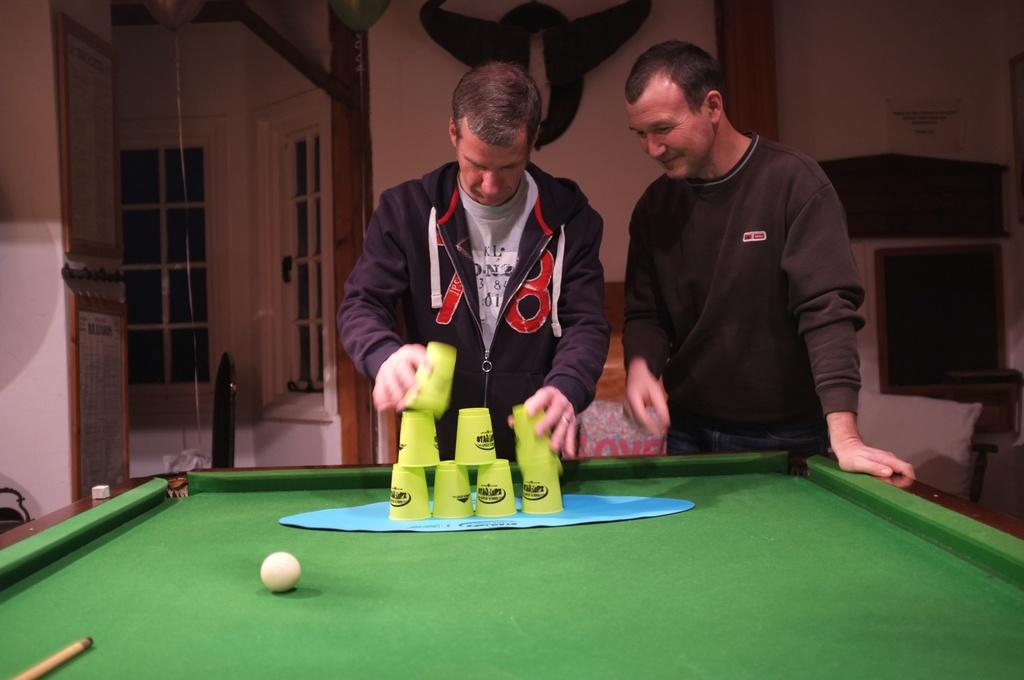How many people are in the image? There are two persons in the image. What are the persons doing in the image? The persons are playing with glasses. What game is being played in the image? The game being played is snooker, as there is a snooker table in the image. What is on the snooker table? A ball and a snooker stick are visible on the snooker table. What can be seen in the background of the image? There is a window in the background of the image. What type of range can be seen in the image? There is no range present in the image. 